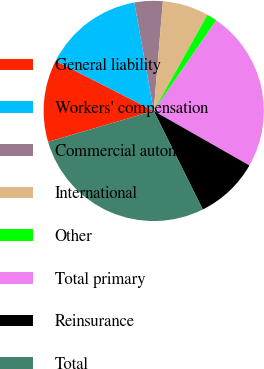Convert chart to OTSL. <chart><loc_0><loc_0><loc_500><loc_500><pie_chart><fcel>General liability<fcel>Workers' compensation<fcel>Commercial automobile<fcel>International<fcel>Other<fcel>Total primary<fcel>Reinsurance<fcel>Total<nl><fcel>12.04%<fcel>14.67%<fcel>4.15%<fcel>6.78%<fcel>1.52%<fcel>23.62%<fcel>9.41%<fcel>27.82%<nl></chart> 